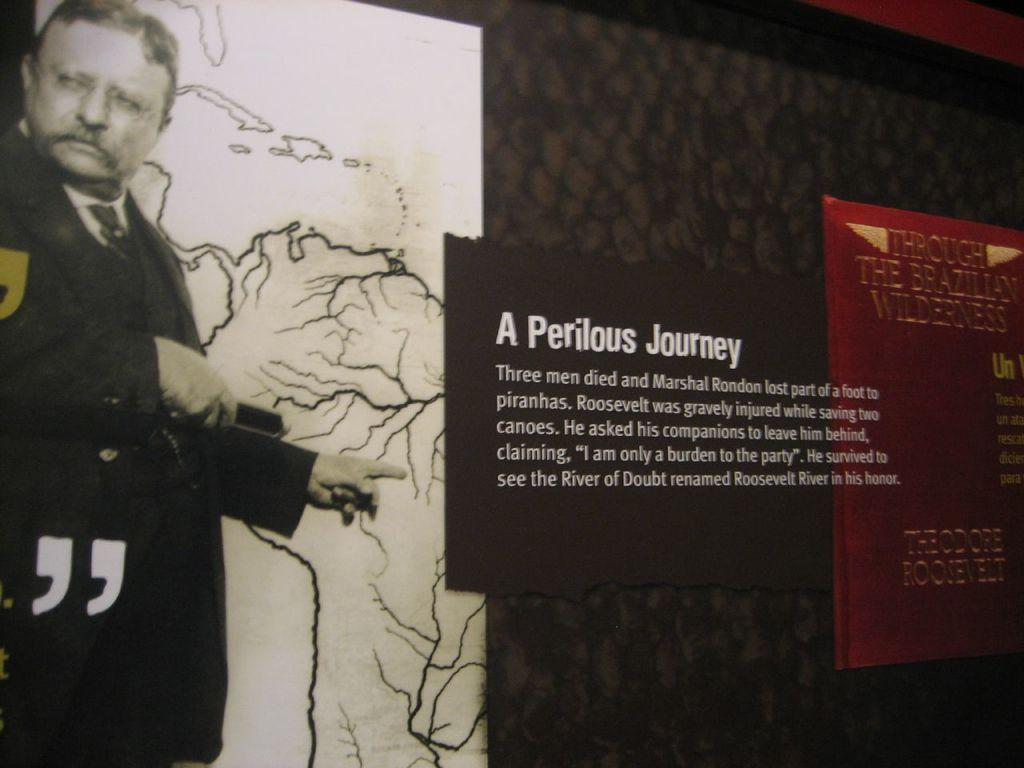<image>
Share a concise interpretation of the image provided. A partly hidden figure points to a Poster entitled "A Perilous Journey" 